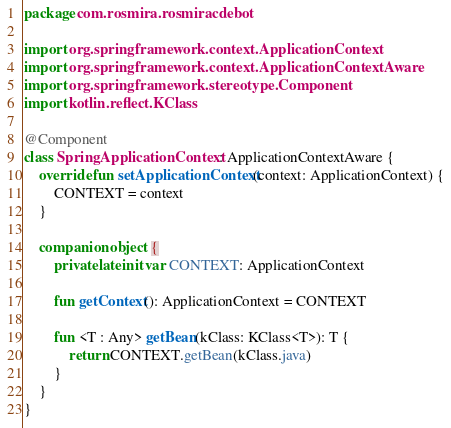<code> <loc_0><loc_0><loc_500><loc_500><_Kotlin_>package com.rosmira.rosmiracdebot

import org.springframework.context.ApplicationContext
import org.springframework.context.ApplicationContextAware
import org.springframework.stereotype.Component
import kotlin.reflect.KClass

@Component
class SpringApplicationContext : ApplicationContextAware {
    override fun setApplicationContext(context: ApplicationContext) {
        CONTEXT = context
    }

    companion object {
        private lateinit var CONTEXT: ApplicationContext

        fun getContext(): ApplicationContext = CONTEXT

        fun <T : Any> getBean(kClass: KClass<T>): T {
            return CONTEXT.getBean(kClass.java)
        }
    }
}</code> 